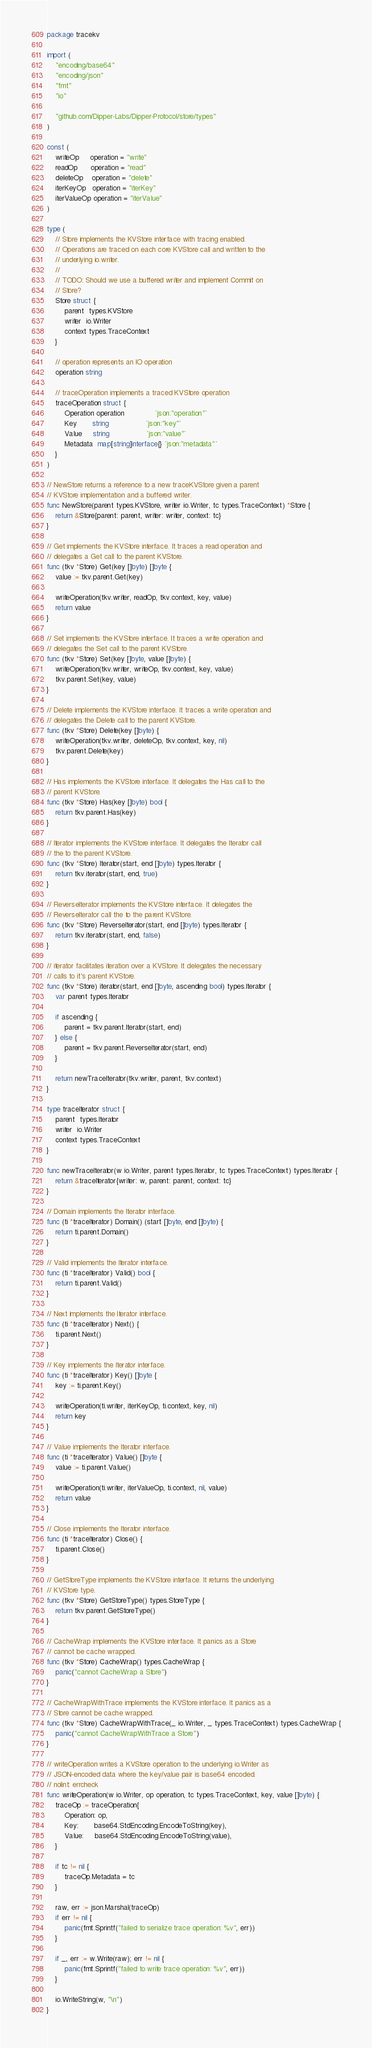Convert code to text. <code><loc_0><loc_0><loc_500><loc_500><_Go_>package tracekv

import (
	"encoding/base64"
	"encoding/json"
	"fmt"
	"io"

	"github.com/Dipper-Labs/Dipper-Protocol/store/types"
)

const (
	writeOp     operation = "write"
	readOp      operation = "read"
	deleteOp    operation = "delete"
	iterKeyOp   operation = "iterKey"
	iterValueOp operation = "iterValue"
)

type (
	// Store implements the KVStore interface with tracing enabled.
	// Operations are traced on each core KVStore call and written to the
	// underlying io.writer.
	//
	// TODO: Should we use a buffered writer and implement Commit on
	// Store?
	Store struct {
		parent  types.KVStore
		writer  io.Writer
		context types.TraceContext
	}

	// operation represents an IO operation
	operation string

	// traceOperation implements a traced KVStore operation
	traceOperation struct {
		Operation operation              `json:"operation"`
		Key       string                 `json:"key"`
		Value     string                 `json:"value"`
		Metadata  map[string]interface{} `json:"metadata"`
	}
)

// NewStore returns a reference to a new traceKVStore given a parent
// KVStore implementation and a buffered writer.
func NewStore(parent types.KVStore, writer io.Writer, tc types.TraceContext) *Store {
	return &Store{parent: parent, writer: writer, context: tc}
}

// Get implements the KVStore interface. It traces a read operation and
// delegates a Get call to the parent KVStore.
func (tkv *Store) Get(key []byte) []byte {
	value := tkv.parent.Get(key)

	writeOperation(tkv.writer, readOp, tkv.context, key, value)
	return value
}

// Set implements the KVStore interface. It traces a write operation and
// delegates the Set call to the parent KVStore.
func (tkv *Store) Set(key []byte, value []byte) {
	writeOperation(tkv.writer, writeOp, tkv.context, key, value)
	tkv.parent.Set(key, value)
}

// Delete implements the KVStore interface. It traces a write operation and
// delegates the Delete call to the parent KVStore.
func (tkv *Store) Delete(key []byte) {
	writeOperation(tkv.writer, deleteOp, tkv.context, key, nil)
	tkv.parent.Delete(key)
}

// Has implements the KVStore interface. It delegates the Has call to the
// parent KVStore.
func (tkv *Store) Has(key []byte) bool {
	return tkv.parent.Has(key)
}

// Iterator implements the KVStore interface. It delegates the Iterator call
// the to the parent KVStore.
func (tkv *Store) Iterator(start, end []byte) types.Iterator {
	return tkv.iterator(start, end, true)
}

// ReverseIterator implements the KVStore interface. It delegates the
// ReverseIterator call the to the parent KVStore.
func (tkv *Store) ReverseIterator(start, end []byte) types.Iterator {
	return tkv.iterator(start, end, false)
}

// iterator facilitates iteration over a KVStore. It delegates the necessary
// calls to it's parent KVStore.
func (tkv *Store) iterator(start, end []byte, ascending bool) types.Iterator {
	var parent types.Iterator

	if ascending {
		parent = tkv.parent.Iterator(start, end)
	} else {
		parent = tkv.parent.ReverseIterator(start, end)
	}

	return newTraceIterator(tkv.writer, parent, tkv.context)
}

type traceIterator struct {
	parent  types.Iterator
	writer  io.Writer
	context types.TraceContext
}

func newTraceIterator(w io.Writer, parent types.Iterator, tc types.TraceContext) types.Iterator {
	return &traceIterator{writer: w, parent: parent, context: tc}
}

// Domain implements the Iterator interface.
func (ti *traceIterator) Domain() (start []byte, end []byte) {
	return ti.parent.Domain()
}

// Valid implements the Iterator interface.
func (ti *traceIterator) Valid() bool {
	return ti.parent.Valid()
}

// Next implements the Iterator interface.
func (ti *traceIterator) Next() {
	ti.parent.Next()
}

// Key implements the Iterator interface.
func (ti *traceIterator) Key() []byte {
	key := ti.parent.Key()

	writeOperation(ti.writer, iterKeyOp, ti.context, key, nil)
	return key
}

// Value implements the Iterator interface.
func (ti *traceIterator) Value() []byte {
	value := ti.parent.Value()

	writeOperation(ti.writer, iterValueOp, ti.context, nil, value)
	return value
}

// Close implements the Iterator interface.
func (ti *traceIterator) Close() {
	ti.parent.Close()
}

// GetStoreType implements the KVStore interface. It returns the underlying
// KVStore type.
func (tkv *Store) GetStoreType() types.StoreType {
	return tkv.parent.GetStoreType()
}

// CacheWrap implements the KVStore interface. It panics as a Store
// cannot be cache wrapped.
func (tkv *Store) CacheWrap() types.CacheWrap {
	panic("cannot CacheWrap a Store")
}

// CacheWrapWithTrace implements the KVStore interface. It panics as a
// Store cannot be cache wrapped.
func (tkv *Store) CacheWrapWithTrace(_ io.Writer, _ types.TraceContext) types.CacheWrap {
	panic("cannot CacheWrapWithTrace a Store")
}

// writeOperation writes a KVStore operation to the underlying io.Writer as
// JSON-encoded data where the key/value pair is base64 encoded.
// nolint: errcheck
func writeOperation(w io.Writer, op operation, tc types.TraceContext, key, value []byte) {
	traceOp := traceOperation{
		Operation: op,
		Key:       base64.StdEncoding.EncodeToString(key),
		Value:     base64.StdEncoding.EncodeToString(value),
	}

	if tc != nil {
		traceOp.Metadata = tc
	}

	raw, err := json.Marshal(traceOp)
	if err != nil {
		panic(fmt.Sprintf("failed to serialize trace operation: %v", err))
	}

	if _, err := w.Write(raw); err != nil {
		panic(fmt.Sprintf("failed to write trace operation: %v", err))
	}

	io.WriteString(w, "\n")
}
</code> 